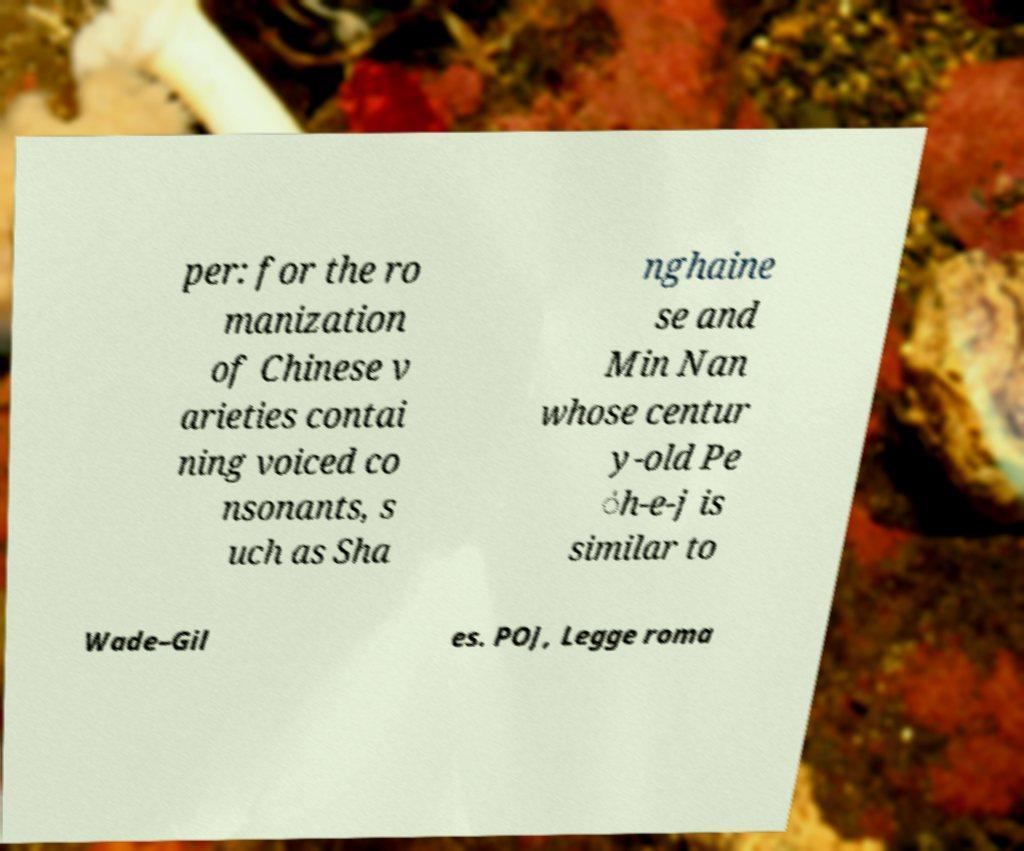Please identify and transcribe the text found in this image. per: for the ro manization of Chinese v arieties contai ning voiced co nsonants, s uch as Sha nghaine se and Min Nan whose centur y-old Pe ̍h-e-j is similar to Wade–Gil es. POJ, Legge roma 